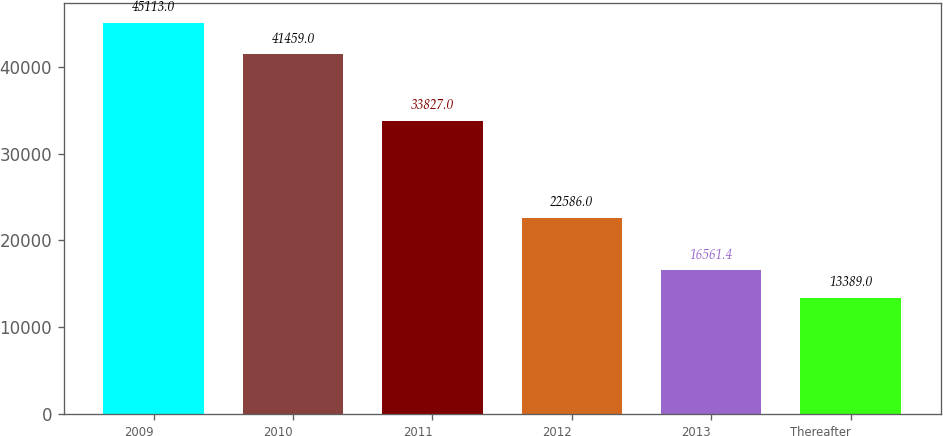Convert chart to OTSL. <chart><loc_0><loc_0><loc_500><loc_500><bar_chart><fcel>2009<fcel>2010<fcel>2011<fcel>2012<fcel>2013<fcel>Thereafter<nl><fcel>45113<fcel>41459<fcel>33827<fcel>22586<fcel>16561.4<fcel>13389<nl></chart> 